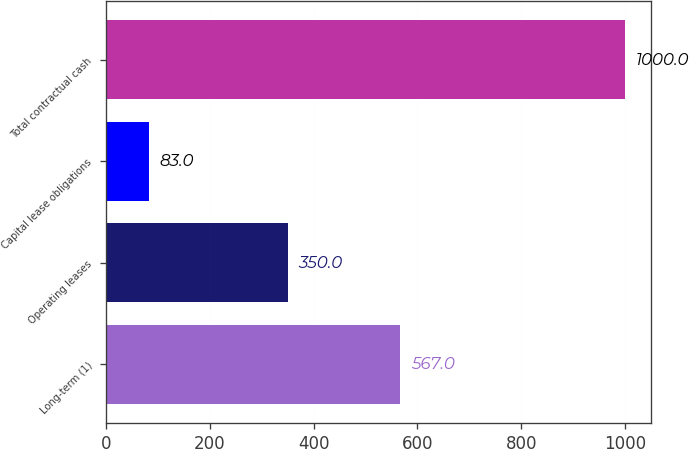Convert chart to OTSL. <chart><loc_0><loc_0><loc_500><loc_500><bar_chart><fcel>Long-term (1)<fcel>Operating leases<fcel>Capital lease obligations<fcel>Total contractual cash<nl><fcel>567<fcel>350<fcel>83<fcel>1000<nl></chart> 